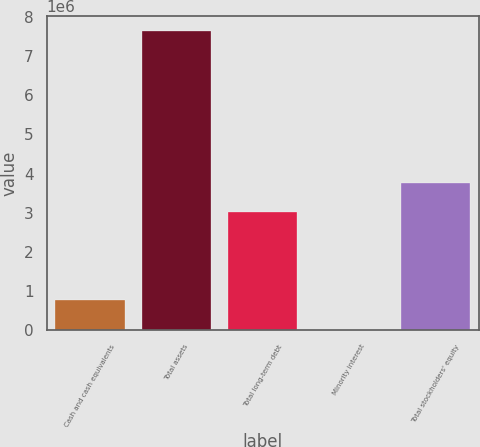Convert chart. <chart><loc_0><loc_0><loc_500><loc_500><bar_chart><fcel>Cash and cash equivalents<fcel>Total assets<fcel>Total long-term debt<fcel>Minority interest<fcel>Total stockholders' equity<nl><fcel>774729<fcel>7.63056e+06<fcel>3.0095e+06<fcel>12970<fcel>3.77126e+06<nl></chart> 